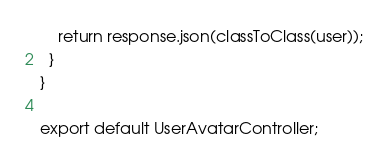Convert code to text. <code><loc_0><loc_0><loc_500><loc_500><_TypeScript_>    return response.json(classToClass(user));
  }
}

export default UserAvatarController;
</code> 